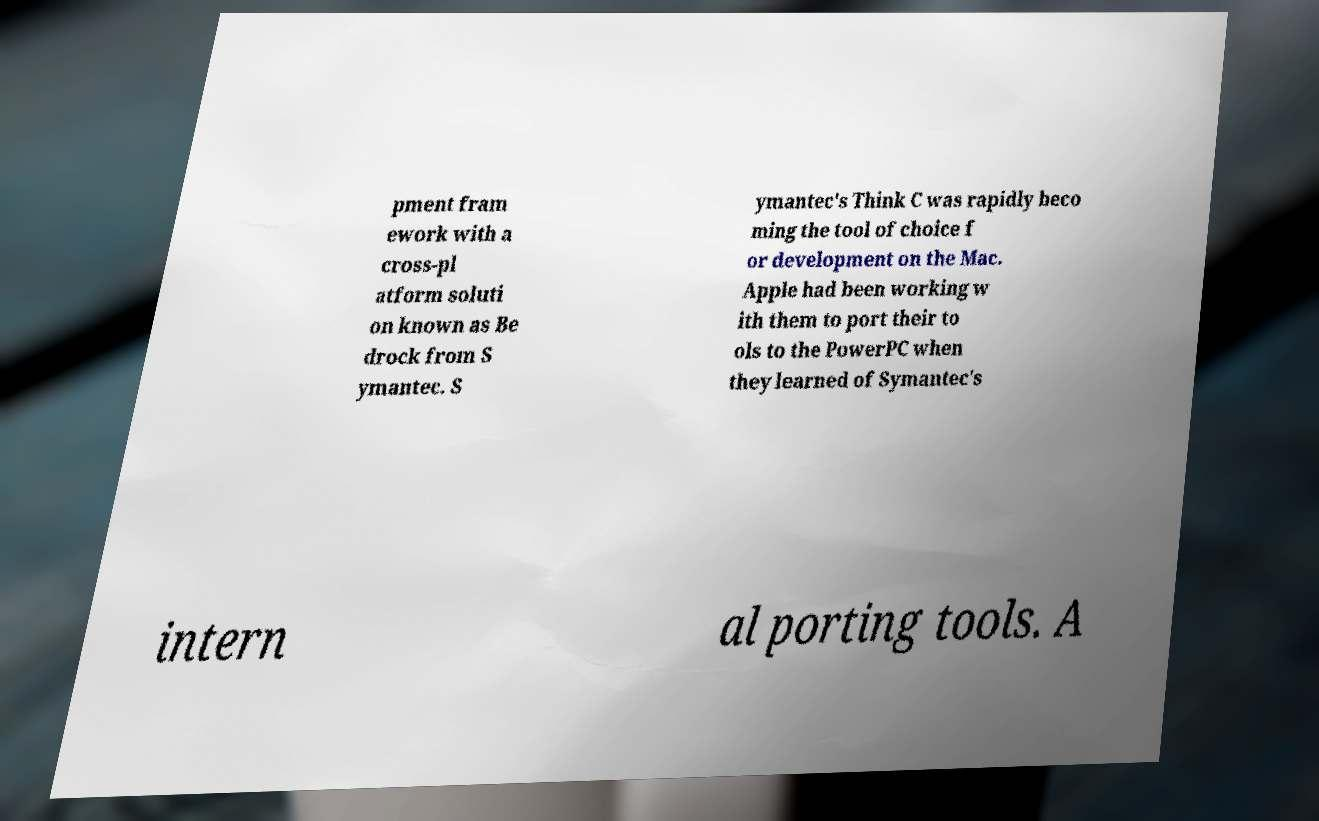For documentation purposes, I need the text within this image transcribed. Could you provide that? pment fram ework with a cross-pl atform soluti on known as Be drock from S ymantec. S ymantec's Think C was rapidly beco ming the tool of choice f or development on the Mac. Apple had been working w ith them to port their to ols to the PowerPC when they learned of Symantec's intern al porting tools. A 